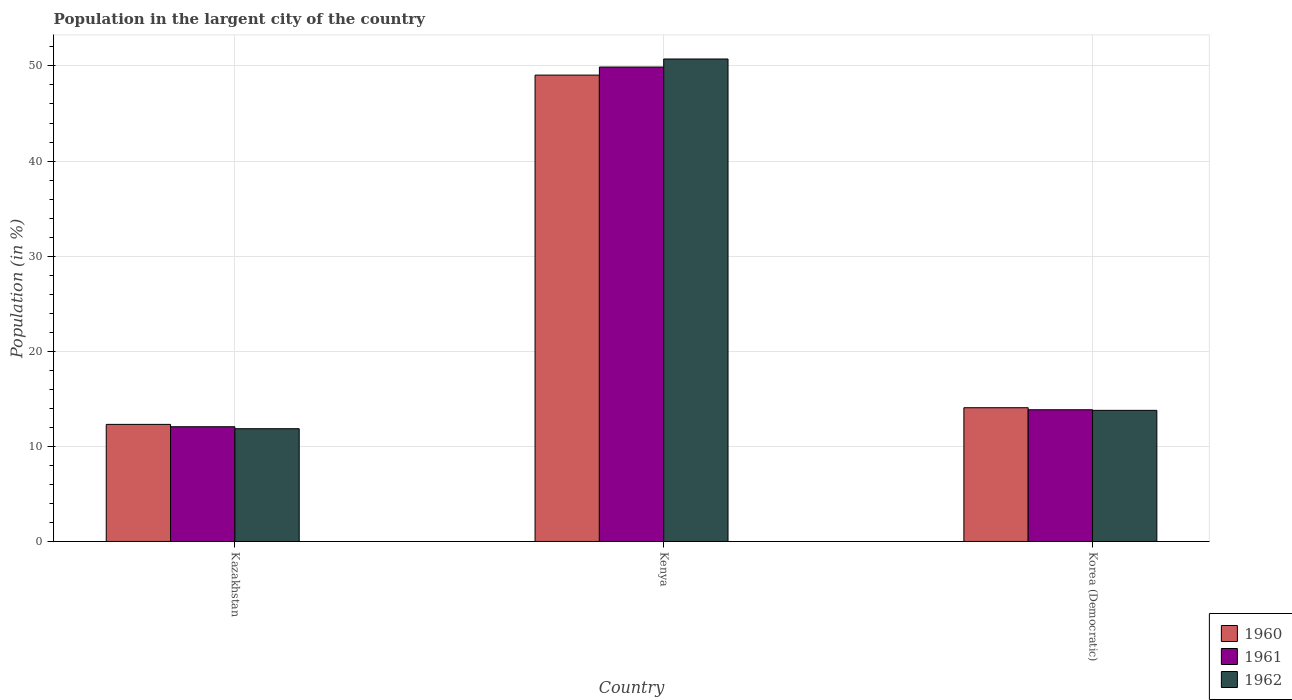How many different coloured bars are there?
Ensure brevity in your answer.  3. Are the number of bars per tick equal to the number of legend labels?
Your response must be concise. Yes. Are the number of bars on each tick of the X-axis equal?
Your answer should be compact. Yes. What is the label of the 1st group of bars from the left?
Give a very brief answer. Kazakhstan. In how many cases, is the number of bars for a given country not equal to the number of legend labels?
Make the answer very short. 0. What is the percentage of population in the largent city in 1962 in Kenya?
Make the answer very short. 50.73. Across all countries, what is the maximum percentage of population in the largent city in 1960?
Your answer should be very brief. 49.04. Across all countries, what is the minimum percentage of population in the largent city in 1962?
Ensure brevity in your answer.  11.86. In which country was the percentage of population in the largent city in 1960 maximum?
Provide a short and direct response. Kenya. In which country was the percentage of population in the largent city in 1960 minimum?
Your answer should be very brief. Kazakhstan. What is the total percentage of population in the largent city in 1961 in the graph?
Give a very brief answer. 75.8. What is the difference between the percentage of population in the largent city in 1962 in Kenya and that in Korea (Democratic)?
Your response must be concise. 36.94. What is the difference between the percentage of population in the largent city in 1962 in Korea (Democratic) and the percentage of population in the largent city in 1961 in Kenya?
Offer a terse response. -36.1. What is the average percentage of population in the largent city in 1961 per country?
Your answer should be very brief. 25.27. What is the difference between the percentage of population in the largent city of/in 1960 and percentage of population in the largent city of/in 1961 in Kenya?
Your answer should be compact. -0.85. In how many countries, is the percentage of population in the largent city in 1961 greater than 44 %?
Your answer should be compact. 1. What is the ratio of the percentage of population in the largent city in 1962 in Kenya to that in Korea (Democratic)?
Provide a short and direct response. 3.68. Is the percentage of population in the largent city in 1961 in Kazakhstan less than that in Kenya?
Ensure brevity in your answer.  Yes. Is the difference between the percentage of population in the largent city in 1960 in Kenya and Korea (Democratic) greater than the difference between the percentage of population in the largent city in 1961 in Kenya and Korea (Democratic)?
Your response must be concise. No. What is the difference between the highest and the second highest percentage of population in the largent city in 1960?
Your answer should be very brief. 36.73. What is the difference between the highest and the lowest percentage of population in the largent city in 1961?
Your response must be concise. 37.82. Is the sum of the percentage of population in the largent city in 1961 in Kenya and Korea (Democratic) greater than the maximum percentage of population in the largent city in 1962 across all countries?
Keep it short and to the point. Yes. What does the 1st bar from the left in Kenya represents?
Make the answer very short. 1960. Is it the case that in every country, the sum of the percentage of population in the largent city in 1961 and percentage of population in the largent city in 1960 is greater than the percentage of population in the largent city in 1962?
Offer a very short reply. Yes. How many bars are there?
Your answer should be compact. 9. Are all the bars in the graph horizontal?
Your response must be concise. No. How many countries are there in the graph?
Ensure brevity in your answer.  3. What is the difference between two consecutive major ticks on the Y-axis?
Provide a short and direct response. 10. Are the values on the major ticks of Y-axis written in scientific E-notation?
Give a very brief answer. No. Does the graph contain any zero values?
Your answer should be very brief. No. What is the title of the graph?
Give a very brief answer. Population in the largent city of the country. What is the label or title of the Y-axis?
Offer a very short reply. Population (in %). What is the Population (in %) in 1960 in Kazakhstan?
Keep it short and to the point. 12.31. What is the Population (in %) in 1961 in Kazakhstan?
Offer a terse response. 12.06. What is the Population (in %) in 1962 in Kazakhstan?
Offer a very short reply. 11.86. What is the Population (in %) in 1960 in Kenya?
Offer a terse response. 49.04. What is the Population (in %) of 1961 in Kenya?
Offer a very short reply. 49.89. What is the Population (in %) of 1962 in Kenya?
Ensure brevity in your answer.  50.73. What is the Population (in %) in 1960 in Korea (Democratic)?
Provide a succinct answer. 14.06. What is the Population (in %) in 1961 in Korea (Democratic)?
Your answer should be very brief. 13.85. What is the Population (in %) in 1962 in Korea (Democratic)?
Make the answer very short. 13.79. Across all countries, what is the maximum Population (in %) in 1960?
Offer a terse response. 49.04. Across all countries, what is the maximum Population (in %) of 1961?
Keep it short and to the point. 49.89. Across all countries, what is the maximum Population (in %) in 1962?
Your answer should be compact. 50.73. Across all countries, what is the minimum Population (in %) in 1960?
Ensure brevity in your answer.  12.31. Across all countries, what is the minimum Population (in %) of 1961?
Your answer should be compact. 12.06. Across all countries, what is the minimum Population (in %) in 1962?
Make the answer very short. 11.86. What is the total Population (in %) of 1960 in the graph?
Your response must be concise. 75.42. What is the total Population (in %) in 1961 in the graph?
Make the answer very short. 75.8. What is the total Population (in %) of 1962 in the graph?
Provide a short and direct response. 76.38. What is the difference between the Population (in %) in 1960 in Kazakhstan and that in Kenya?
Offer a very short reply. -36.73. What is the difference between the Population (in %) in 1961 in Kazakhstan and that in Kenya?
Your response must be concise. -37.82. What is the difference between the Population (in %) of 1962 in Kazakhstan and that in Kenya?
Your response must be concise. -38.88. What is the difference between the Population (in %) in 1960 in Kazakhstan and that in Korea (Democratic)?
Make the answer very short. -1.75. What is the difference between the Population (in %) in 1961 in Kazakhstan and that in Korea (Democratic)?
Give a very brief answer. -1.79. What is the difference between the Population (in %) of 1962 in Kazakhstan and that in Korea (Democratic)?
Give a very brief answer. -1.93. What is the difference between the Population (in %) of 1960 in Kenya and that in Korea (Democratic)?
Ensure brevity in your answer.  34.97. What is the difference between the Population (in %) of 1961 in Kenya and that in Korea (Democratic)?
Provide a short and direct response. 36.04. What is the difference between the Population (in %) in 1962 in Kenya and that in Korea (Democratic)?
Your answer should be very brief. 36.94. What is the difference between the Population (in %) of 1960 in Kazakhstan and the Population (in %) of 1961 in Kenya?
Offer a very short reply. -37.57. What is the difference between the Population (in %) of 1960 in Kazakhstan and the Population (in %) of 1962 in Kenya?
Offer a terse response. -38.42. What is the difference between the Population (in %) in 1961 in Kazakhstan and the Population (in %) in 1962 in Kenya?
Keep it short and to the point. -38.67. What is the difference between the Population (in %) of 1960 in Kazakhstan and the Population (in %) of 1961 in Korea (Democratic)?
Your answer should be compact. -1.54. What is the difference between the Population (in %) in 1960 in Kazakhstan and the Population (in %) in 1962 in Korea (Democratic)?
Your response must be concise. -1.47. What is the difference between the Population (in %) in 1961 in Kazakhstan and the Population (in %) in 1962 in Korea (Democratic)?
Provide a short and direct response. -1.72. What is the difference between the Population (in %) in 1960 in Kenya and the Population (in %) in 1961 in Korea (Democratic)?
Keep it short and to the point. 35.19. What is the difference between the Population (in %) in 1960 in Kenya and the Population (in %) in 1962 in Korea (Democratic)?
Your response must be concise. 35.25. What is the difference between the Population (in %) of 1961 in Kenya and the Population (in %) of 1962 in Korea (Democratic)?
Offer a very short reply. 36.1. What is the average Population (in %) of 1960 per country?
Make the answer very short. 25.14. What is the average Population (in %) in 1961 per country?
Keep it short and to the point. 25.27. What is the average Population (in %) in 1962 per country?
Make the answer very short. 25.46. What is the difference between the Population (in %) of 1960 and Population (in %) of 1961 in Kazakhstan?
Ensure brevity in your answer.  0.25. What is the difference between the Population (in %) of 1960 and Population (in %) of 1962 in Kazakhstan?
Make the answer very short. 0.46. What is the difference between the Population (in %) in 1961 and Population (in %) in 1962 in Kazakhstan?
Your answer should be very brief. 0.21. What is the difference between the Population (in %) in 1960 and Population (in %) in 1961 in Kenya?
Your answer should be very brief. -0.85. What is the difference between the Population (in %) of 1960 and Population (in %) of 1962 in Kenya?
Make the answer very short. -1.69. What is the difference between the Population (in %) of 1961 and Population (in %) of 1962 in Kenya?
Keep it short and to the point. -0.85. What is the difference between the Population (in %) of 1960 and Population (in %) of 1961 in Korea (Democratic)?
Make the answer very short. 0.21. What is the difference between the Population (in %) in 1960 and Population (in %) in 1962 in Korea (Democratic)?
Keep it short and to the point. 0.28. What is the difference between the Population (in %) in 1961 and Population (in %) in 1962 in Korea (Democratic)?
Offer a terse response. 0.06. What is the ratio of the Population (in %) of 1960 in Kazakhstan to that in Kenya?
Your answer should be very brief. 0.25. What is the ratio of the Population (in %) in 1961 in Kazakhstan to that in Kenya?
Offer a very short reply. 0.24. What is the ratio of the Population (in %) in 1962 in Kazakhstan to that in Kenya?
Your response must be concise. 0.23. What is the ratio of the Population (in %) of 1960 in Kazakhstan to that in Korea (Democratic)?
Ensure brevity in your answer.  0.88. What is the ratio of the Population (in %) in 1961 in Kazakhstan to that in Korea (Democratic)?
Ensure brevity in your answer.  0.87. What is the ratio of the Population (in %) of 1962 in Kazakhstan to that in Korea (Democratic)?
Ensure brevity in your answer.  0.86. What is the ratio of the Population (in %) in 1960 in Kenya to that in Korea (Democratic)?
Your answer should be compact. 3.49. What is the ratio of the Population (in %) in 1961 in Kenya to that in Korea (Democratic)?
Your response must be concise. 3.6. What is the ratio of the Population (in %) in 1962 in Kenya to that in Korea (Democratic)?
Your answer should be compact. 3.68. What is the difference between the highest and the second highest Population (in %) of 1960?
Your answer should be compact. 34.97. What is the difference between the highest and the second highest Population (in %) in 1961?
Provide a short and direct response. 36.04. What is the difference between the highest and the second highest Population (in %) in 1962?
Give a very brief answer. 36.94. What is the difference between the highest and the lowest Population (in %) of 1960?
Keep it short and to the point. 36.73. What is the difference between the highest and the lowest Population (in %) in 1961?
Provide a short and direct response. 37.82. What is the difference between the highest and the lowest Population (in %) of 1962?
Ensure brevity in your answer.  38.88. 